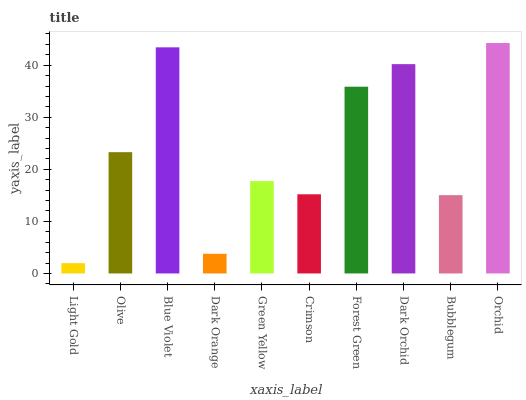Is Light Gold the minimum?
Answer yes or no. Yes. Is Orchid the maximum?
Answer yes or no. Yes. Is Olive the minimum?
Answer yes or no. No. Is Olive the maximum?
Answer yes or no. No. Is Olive greater than Light Gold?
Answer yes or no. Yes. Is Light Gold less than Olive?
Answer yes or no. Yes. Is Light Gold greater than Olive?
Answer yes or no. No. Is Olive less than Light Gold?
Answer yes or no. No. Is Olive the high median?
Answer yes or no. Yes. Is Green Yellow the low median?
Answer yes or no. Yes. Is Forest Green the high median?
Answer yes or no. No. Is Blue Violet the low median?
Answer yes or no. No. 